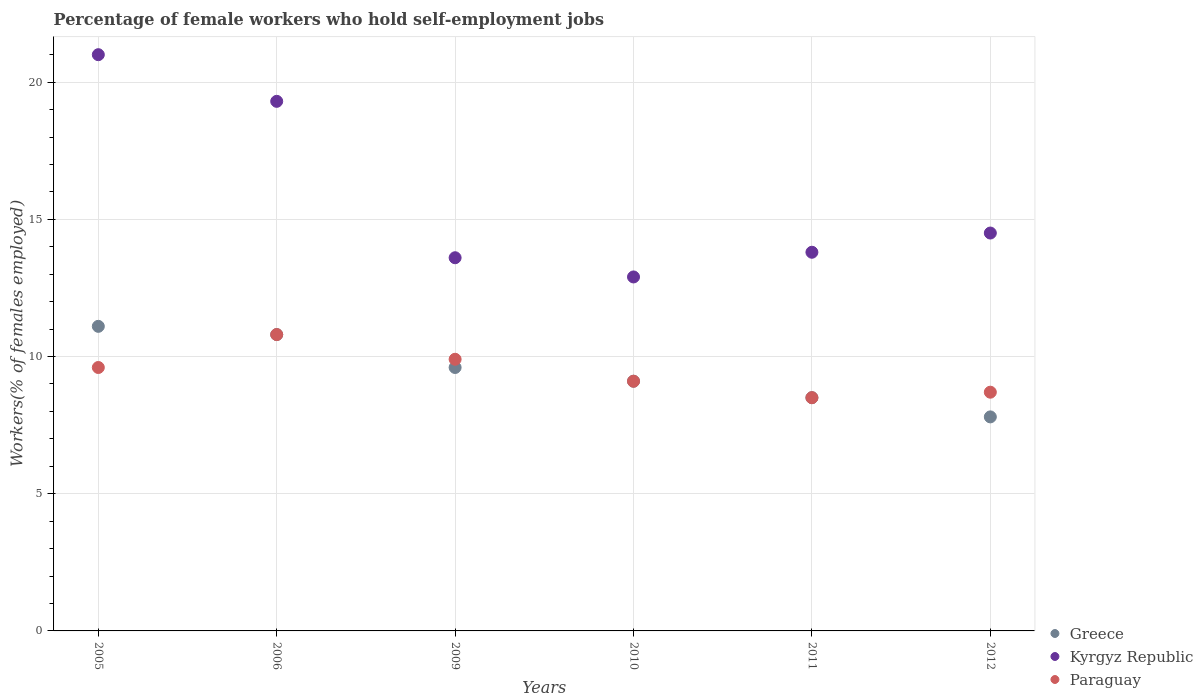What is the percentage of self-employed female workers in Kyrgyz Republic in 2005?
Your response must be concise. 21. Across all years, what is the maximum percentage of self-employed female workers in Paraguay?
Offer a very short reply. 10.8. In which year was the percentage of self-employed female workers in Greece maximum?
Your answer should be very brief. 2005. What is the total percentage of self-employed female workers in Greece in the graph?
Give a very brief answer. 56.9. What is the difference between the percentage of self-employed female workers in Paraguay in 2006 and that in 2011?
Offer a terse response. 2.3. What is the difference between the percentage of self-employed female workers in Kyrgyz Republic in 2011 and the percentage of self-employed female workers in Paraguay in 2012?
Give a very brief answer. 5.1. What is the average percentage of self-employed female workers in Paraguay per year?
Your answer should be very brief. 9.43. In the year 2009, what is the difference between the percentage of self-employed female workers in Kyrgyz Republic and percentage of self-employed female workers in Paraguay?
Ensure brevity in your answer.  3.7. What is the ratio of the percentage of self-employed female workers in Greece in 2005 to that in 2011?
Provide a succinct answer. 1.31. What is the difference between the highest and the second highest percentage of self-employed female workers in Kyrgyz Republic?
Provide a short and direct response. 1.7. What is the difference between the highest and the lowest percentage of self-employed female workers in Paraguay?
Provide a short and direct response. 2.3. Is the percentage of self-employed female workers in Kyrgyz Republic strictly less than the percentage of self-employed female workers in Paraguay over the years?
Make the answer very short. No. How many years are there in the graph?
Offer a very short reply. 6. Does the graph contain grids?
Your answer should be compact. Yes. Where does the legend appear in the graph?
Keep it short and to the point. Bottom right. How many legend labels are there?
Provide a short and direct response. 3. What is the title of the graph?
Make the answer very short. Percentage of female workers who hold self-employment jobs. Does "Jamaica" appear as one of the legend labels in the graph?
Your answer should be compact. No. What is the label or title of the X-axis?
Your response must be concise. Years. What is the label or title of the Y-axis?
Ensure brevity in your answer.  Workers(% of females employed). What is the Workers(% of females employed) of Greece in 2005?
Offer a very short reply. 11.1. What is the Workers(% of females employed) in Kyrgyz Republic in 2005?
Offer a terse response. 21. What is the Workers(% of females employed) in Paraguay in 2005?
Provide a succinct answer. 9.6. What is the Workers(% of females employed) of Greece in 2006?
Provide a succinct answer. 10.8. What is the Workers(% of females employed) of Kyrgyz Republic in 2006?
Ensure brevity in your answer.  19.3. What is the Workers(% of females employed) in Paraguay in 2006?
Offer a terse response. 10.8. What is the Workers(% of females employed) in Greece in 2009?
Provide a short and direct response. 9.6. What is the Workers(% of females employed) of Kyrgyz Republic in 2009?
Your answer should be compact. 13.6. What is the Workers(% of females employed) in Paraguay in 2009?
Your answer should be very brief. 9.9. What is the Workers(% of females employed) of Greece in 2010?
Ensure brevity in your answer.  9.1. What is the Workers(% of females employed) of Kyrgyz Republic in 2010?
Give a very brief answer. 12.9. What is the Workers(% of females employed) of Paraguay in 2010?
Provide a short and direct response. 9.1. What is the Workers(% of females employed) in Kyrgyz Republic in 2011?
Keep it short and to the point. 13.8. What is the Workers(% of females employed) of Greece in 2012?
Keep it short and to the point. 7.8. What is the Workers(% of females employed) in Paraguay in 2012?
Provide a short and direct response. 8.7. Across all years, what is the maximum Workers(% of females employed) of Greece?
Offer a very short reply. 11.1. Across all years, what is the maximum Workers(% of females employed) of Kyrgyz Republic?
Offer a very short reply. 21. Across all years, what is the maximum Workers(% of females employed) of Paraguay?
Your response must be concise. 10.8. Across all years, what is the minimum Workers(% of females employed) in Greece?
Your answer should be very brief. 7.8. Across all years, what is the minimum Workers(% of females employed) of Kyrgyz Republic?
Give a very brief answer. 12.9. What is the total Workers(% of females employed) of Greece in the graph?
Your answer should be very brief. 56.9. What is the total Workers(% of females employed) of Kyrgyz Republic in the graph?
Your answer should be very brief. 95.1. What is the total Workers(% of females employed) of Paraguay in the graph?
Ensure brevity in your answer.  56.6. What is the difference between the Workers(% of females employed) in Greece in 2005 and that in 2006?
Your answer should be very brief. 0.3. What is the difference between the Workers(% of females employed) in Greece in 2005 and that in 2009?
Give a very brief answer. 1.5. What is the difference between the Workers(% of females employed) in Kyrgyz Republic in 2005 and that in 2010?
Your answer should be very brief. 8.1. What is the difference between the Workers(% of females employed) of Paraguay in 2005 and that in 2010?
Your answer should be compact. 0.5. What is the difference between the Workers(% of females employed) in Greece in 2005 and that in 2011?
Offer a terse response. 2.6. What is the difference between the Workers(% of females employed) of Kyrgyz Republic in 2005 and that in 2011?
Give a very brief answer. 7.2. What is the difference between the Workers(% of females employed) in Kyrgyz Republic in 2005 and that in 2012?
Ensure brevity in your answer.  6.5. What is the difference between the Workers(% of females employed) of Kyrgyz Republic in 2006 and that in 2009?
Offer a terse response. 5.7. What is the difference between the Workers(% of females employed) of Paraguay in 2006 and that in 2009?
Give a very brief answer. 0.9. What is the difference between the Workers(% of females employed) in Greece in 2006 and that in 2010?
Offer a very short reply. 1.7. What is the difference between the Workers(% of females employed) of Kyrgyz Republic in 2006 and that in 2010?
Provide a short and direct response. 6.4. What is the difference between the Workers(% of females employed) in Paraguay in 2006 and that in 2010?
Your response must be concise. 1.7. What is the difference between the Workers(% of females employed) of Paraguay in 2006 and that in 2011?
Provide a succinct answer. 2.3. What is the difference between the Workers(% of females employed) in Greece in 2006 and that in 2012?
Ensure brevity in your answer.  3. What is the difference between the Workers(% of females employed) of Kyrgyz Republic in 2006 and that in 2012?
Offer a terse response. 4.8. What is the difference between the Workers(% of females employed) of Paraguay in 2006 and that in 2012?
Offer a terse response. 2.1. What is the difference between the Workers(% of females employed) in Greece in 2009 and that in 2010?
Give a very brief answer. 0.5. What is the difference between the Workers(% of females employed) in Greece in 2009 and that in 2011?
Ensure brevity in your answer.  1.1. What is the difference between the Workers(% of females employed) in Kyrgyz Republic in 2009 and that in 2011?
Your response must be concise. -0.2. What is the difference between the Workers(% of females employed) in Kyrgyz Republic in 2009 and that in 2012?
Your answer should be compact. -0.9. What is the difference between the Workers(% of females employed) in Paraguay in 2009 and that in 2012?
Offer a terse response. 1.2. What is the difference between the Workers(% of females employed) in Kyrgyz Republic in 2011 and that in 2012?
Offer a terse response. -0.7. What is the difference between the Workers(% of females employed) in Paraguay in 2011 and that in 2012?
Give a very brief answer. -0.2. What is the difference between the Workers(% of females employed) in Greece in 2005 and the Workers(% of females employed) in Paraguay in 2006?
Offer a terse response. 0.3. What is the difference between the Workers(% of females employed) of Greece in 2005 and the Workers(% of females employed) of Paraguay in 2009?
Provide a short and direct response. 1.2. What is the difference between the Workers(% of females employed) of Greece in 2005 and the Workers(% of females employed) of Kyrgyz Republic in 2010?
Keep it short and to the point. -1.8. What is the difference between the Workers(% of females employed) in Greece in 2005 and the Workers(% of females employed) in Paraguay in 2010?
Your answer should be compact. 2. What is the difference between the Workers(% of females employed) in Greece in 2005 and the Workers(% of females employed) in Paraguay in 2011?
Your response must be concise. 2.6. What is the difference between the Workers(% of females employed) in Kyrgyz Republic in 2005 and the Workers(% of females employed) in Paraguay in 2011?
Your answer should be compact. 12.5. What is the difference between the Workers(% of females employed) in Greece in 2005 and the Workers(% of females employed) in Paraguay in 2012?
Offer a terse response. 2.4. What is the difference between the Workers(% of females employed) of Greece in 2006 and the Workers(% of females employed) of Kyrgyz Republic in 2009?
Provide a short and direct response. -2.8. What is the difference between the Workers(% of females employed) in Greece in 2006 and the Workers(% of females employed) in Kyrgyz Republic in 2010?
Your response must be concise. -2.1. What is the difference between the Workers(% of females employed) of Greece in 2006 and the Workers(% of females employed) of Kyrgyz Republic in 2011?
Keep it short and to the point. -3. What is the difference between the Workers(% of females employed) in Greece in 2006 and the Workers(% of females employed) in Paraguay in 2011?
Ensure brevity in your answer.  2.3. What is the difference between the Workers(% of females employed) of Kyrgyz Republic in 2006 and the Workers(% of females employed) of Paraguay in 2011?
Your response must be concise. 10.8. What is the difference between the Workers(% of females employed) of Greece in 2006 and the Workers(% of females employed) of Kyrgyz Republic in 2012?
Make the answer very short. -3.7. What is the difference between the Workers(% of females employed) in Greece in 2006 and the Workers(% of females employed) in Paraguay in 2012?
Provide a short and direct response. 2.1. What is the difference between the Workers(% of females employed) of Greece in 2009 and the Workers(% of females employed) of Kyrgyz Republic in 2010?
Offer a terse response. -3.3. What is the difference between the Workers(% of females employed) of Kyrgyz Republic in 2009 and the Workers(% of females employed) of Paraguay in 2010?
Your answer should be very brief. 4.5. What is the difference between the Workers(% of females employed) in Greece in 2009 and the Workers(% of females employed) in Kyrgyz Republic in 2011?
Keep it short and to the point. -4.2. What is the difference between the Workers(% of females employed) of Kyrgyz Republic in 2009 and the Workers(% of females employed) of Paraguay in 2011?
Your answer should be compact. 5.1. What is the difference between the Workers(% of females employed) of Greece in 2009 and the Workers(% of females employed) of Kyrgyz Republic in 2012?
Provide a short and direct response. -4.9. What is the difference between the Workers(% of females employed) of Greece in 2009 and the Workers(% of females employed) of Paraguay in 2012?
Offer a terse response. 0.9. What is the difference between the Workers(% of females employed) in Greece in 2010 and the Workers(% of females employed) in Kyrgyz Republic in 2011?
Your answer should be very brief. -4.7. What is the difference between the Workers(% of females employed) in Greece in 2010 and the Workers(% of females employed) in Kyrgyz Republic in 2012?
Keep it short and to the point. -5.4. What is the difference between the Workers(% of females employed) of Greece in 2011 and the Workers(% of females employed) of Kyrgyz Republic in 2012?
Your response must be concise. -6. What is the average Workers(% of females employed) of Greece per year?
Make the answer very short. 9.48. What is the average Workers(% of females employed) of Kyrgyz Republic per year?
Your answer should be very brief. 15.85. What is the average Workers(% of females employed) of Paraguay per year?
Your response must be concise. 9.43. In the year 2005, what is the difference between the Workers(% of females employed) in Greece and Workers(% of females employed) in Kyrgyz Republic?
Your response must be concise. -9.9. In the year 2005, what is the difference between the Workers(% of females employed) in Greece and Workers(% of females employed) in Paraguay?
Give a very brief answer. 1.5. In the year 2006, what is the difference between the Workers(% of females employed) of Kyrgyz Republic and Workers(% of females employed) of Paraguay?
Keep it short and to the point. 8.5. In the year 2009, what is the difference between the Workers(% of females employed) in Greece and Workers(% of females employed) in Kyrgyz Republic?
Offer a terse response. -4. In the year 2010, what is the difference between the Workers(% of females employed) in Greece and Workers(% of females employed) in Kyrgyz Republic?
Keep it short and to the point. -3.8. In the year 2011, what is the difference between the Workers(% of females employed) in Greece and Workers(% of females employed) in Paraguay?
Provide a succinct answer. 0. In the year 2012, what is the difference between the Workers(% of females employed) of Greece and Workers(% of females employed) of Kyrgyz Republic?
Offer a very short reply. -6.7. What is the ratio of the Workers(% of females employed) in Greece in 2005 to that in 2006?
Provide a succinct answer. 1.03. What is the ratio of the Workers(% of females employed) in Kyrgyz Republic in 2005 to that in 2006?
Your answer should be compact. 1.09. What is the ratio of the Workers(% of females employed) in Paraguay in 2005 to that in 2006?
Offer a terse response. 0.89. What is the ratio of the Workers(% of females employed) in Greece in 2005 to that in 2009?
Ensure brevity in your answer.  1.16. What is the ratio of the Workers(% of females employed) of Kyrgyz Republic in 2005 to that in 2009?
Ensure brevity in your answer.  1.54. What is the ratio of the Workers(% of females employed) in Paraguay in 2005 to that in 2009?
Offer a terse response. 0.97. What is the ratio of the Workers(% of females employed) in Greece in 2005 to that in 2010?
Provide a succinct answer. 1.22. What is the ratio of the Workers(% of females employed) in Kyrgyz Republic in 2005 to that in 2010?
Your response must be concise. 1.63. What is the ratio of the Workers(% of females employed) of Paraguay in 2005 to that in 2010?
Ensure brevity in your answer.  1.05. What is the ratio of the Workers(% of females employed) in Greece in 2005 to that in 2011?
Your response must be concise. 1.31. What is the ratio of the Workers(% of females employed) in Kyrgyz Republic in 2005 to that in 2011?
Your answer should be very brief. 1.52. What is the ratio of the Workers(% of females employed) in Paraguay in 2005 to that in 2011?
Give a very brief answer. 1.13. What is the ratio of the Workers(% of females employed) of Greece in 2005 to that in 2012?
Give a very brief answer. 1.42. What is the ratio of the Workers(% of females employed) in Kyrgyz Republic in 2005 to that in 2012?
Make the answer very short. 1.45. What is the ratio of the Workers(% of females employed) in Paraguay in 2005 to that in 2012?
Give a very brief answer. 1.1. What is the ratio of the Workers(% of females employed) of Greece in 2006 to that in 2009?
Keep it short and to the point. 1.12. What is the ratio of the Workers(% of females employed) of Kyrgyz Republic in 2006 to that in 2009?
Give a very brief answer. 1.42. What is the ratio of the Workers(% of females employed) of Greece in 2006 to that in 2010?
Provide a succinct answer. 1.19. What is the ratio of the Workers(% of females employed) of Kyrgyz Republic in 2006 to that in 2010?
Your response must be concise. 1.5. What is the ratio of the Workers(% of females employed) of Paraguay in 2006 to that in 2010?
Ensure brevity in your answer.  1.19. What is the ratio of the Workers(% of females employed) in Greece in 2006 to that in 2011?
Your response must be concise. 1.27. What is the ratio of the Workers(% of females employed) in Kyrgyz Republic in 2006 to that in 2011?
Ensure brevity in your answer.  1.4. What is the ratio of the Workers(% of females employed) in Paraguay in 2006 to that in 2011?
Make the answer very short. 1.27. What is the ratio of the Workers(% of females employed) of Greece in 2006 to that in 2012?
Offer a very short reply. 1.38. What is the ratio of the Workers(% of females employed) in Kyrgyz Republic in 2006 to that in 2012?
Your answer should be compact. 1.33. What is the ratio of the Workers(% of females employed) in Paraguay in 2006 to that in 2012?
Keep it short and to the point. 1.24. What is the ratio of the Workers(% of females employed) in Greece in 2009 to that in 2010?
Provide a short and direct response. 1.05. What is the ratio of the Workers(% of females employed) of Kyrgyz Republic in 2009 to that in 2010?
Provide a succinct answer. 1.05. What is the ratio of the Workers(% of females employed) of Paraguay in 2009 to that in 2010?
Offer a terse response. 1.09. What is the ratio of the Workers(% of females employed) of Greece in 2009 to that in 2011?
Your answer should be compact. 1.13. What is the ratio of the Workers(% of females employed) of Kyrgyz Republic in 2009 to that in 2011?
Make the answer very short. 0.99. What is the ratio of the Workers(% of females employed) in Paraguay in 2009 to that in 2011?
Your response must be concise. 1.16. What is the ratio of the Workers(% of females employed) of Greece in 2009 to that in 2012?
Make the answer very short. 1.23. What is the ratio of the Workers(% of females employed) of Kyrgyz Republic in 2009 to that in 2012?
Your response must be concise. 0.94. What is the ratio of the Workers(% of females employed) in Paraguay in 2009 to that in 2012?
Ensure brevity in your answer.  1.14. What is the ratio of the Workers(% of females employed) in Greece in 2010 to that in 2011?
Give a very brief answer. 1.07. What is the ratio of the Workers(% of females employed) in Kyrgyz Republic in 2010 to that in 2011?
Ensure brevity in your answer.  0.93. What is the ratio of the Workers(% of females employed) of Paraguay in 2010 to that in 2011?
Make the answer very short. 1.07. What is the ratio of the Workers(% of females employed) in Greece in 2010 to that in 2012?
Keep it short and to the point. 1.17. What is the ratio of the Workers(% of females employed) of Kyrgyz Republic in 2010 to that in 2012?
Ensure brevity in your answer.  0.89. What is the ratio of the Workers(% of females employed) of Paraguay in 2010 to that in 2012?
Offer a very short reply. 1.05. What is the ratio of the Workers(% of females employed) of Greece in 2011 to that in 2012?
Offer a terse response. 1.09. What is the ratio of the Workers(% of females employed) of Kyrgyz Republic in 2011 to that in 2012?
Your answer should be very brief. 0.95. What is the ratio of the Workers(% of females employed) in Paraguay in 2011 to that in 2012?
Ensure brevity in your answer.  0.98. What is the difference between the highest and the second highest Workers(% of females employed) of Greece?
Make the answer very short. 0.3. What is the difference between the highest and the lowest Workers(% of females employed) of Greece?
Your answer should be compact. 3.3. What is the difference between the highest and the lowest Workers(% of females employed) of Kyrgyz Republic?
Make the answer very short. 8.1. What is the difference between the highest and the lowest Workers(% of females employed) in Paraguay?
Give a very brief answer. 2.3. 